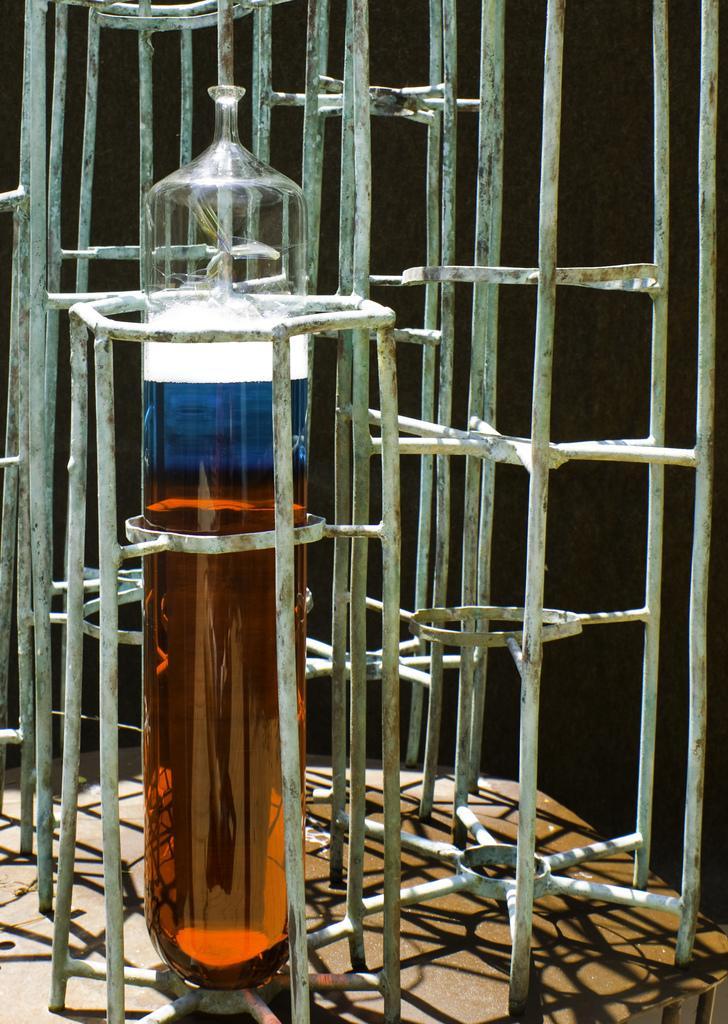In one or two sentences, can you explain what this image depicts? As we can see in the image there is a ladder and liquid in glass. 